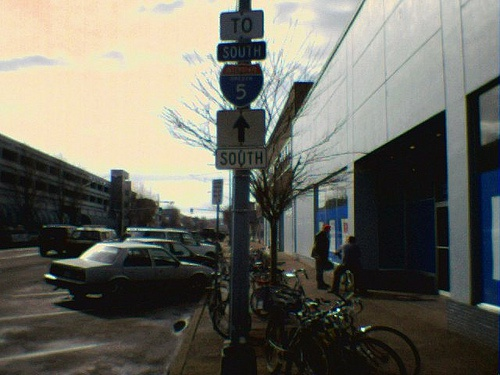Describe the objects in this image and their specific colors. I can see car in tan, black, darkgray, gray, and beige tones, bicycle in tan, black, darkgreen, and gray tones, bicycle in tan, black, darkgreen, and teal tones, bicycle in tan, black, and gray tones, and bicycle in tan, black, and gray tones in this image. 